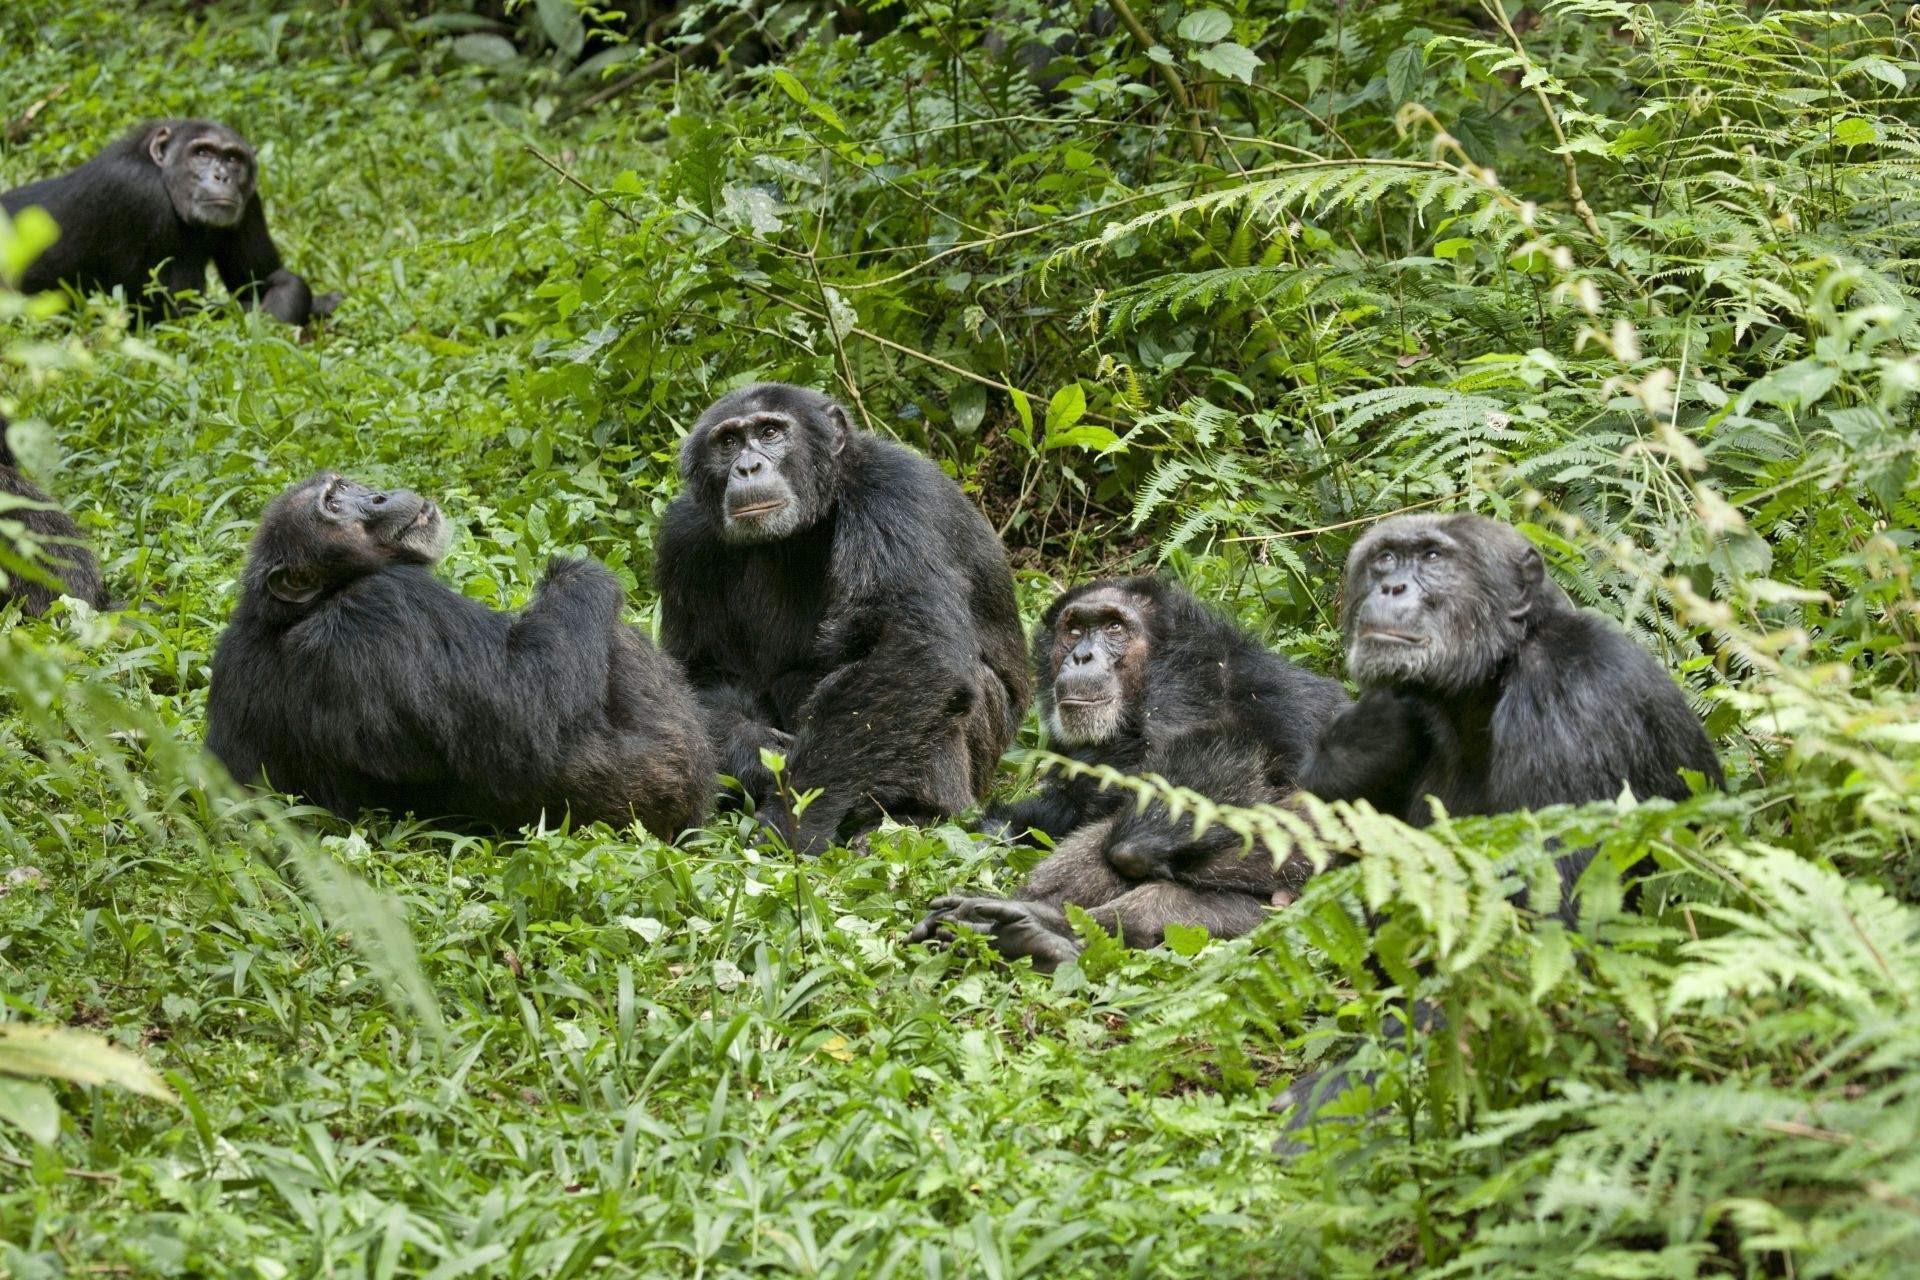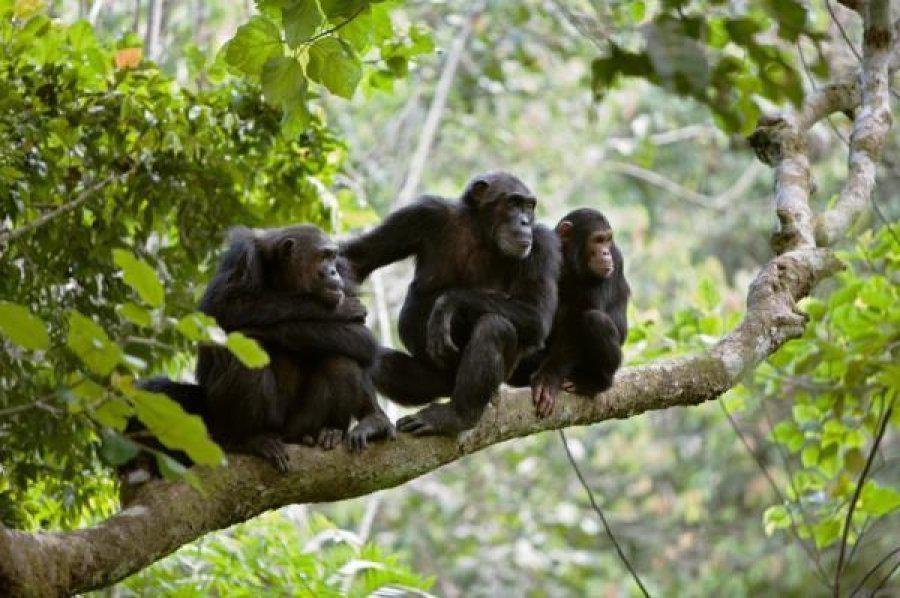The first image is the image on the left, the second image is the image on the right. Examine the images to the left and right. Is the description "At least one chimp is squatting on a somewhat horizontal branch, surrounded by foliage." accurate? Answer yes or no. Yes. The first image is the image on the left, the second image is the image on the right. Considering the images on both sides, is "There are chimpanzees sitting on a suspended tree branch." valid? Answer yes or no. Yes. 